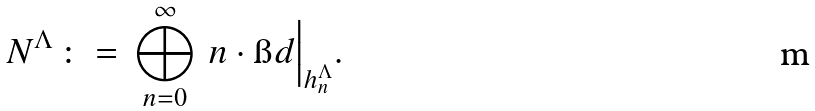<formula> <loc_0><loc_0><loc_500><loc_500>N ^ { \Lambda } \, \colon = \, \bigoplus _ { n = 0 } ^ { \infty } \, n \cdot \i d \Big | _ { h _ { n } ^ { \Lambda } } .</formula> 